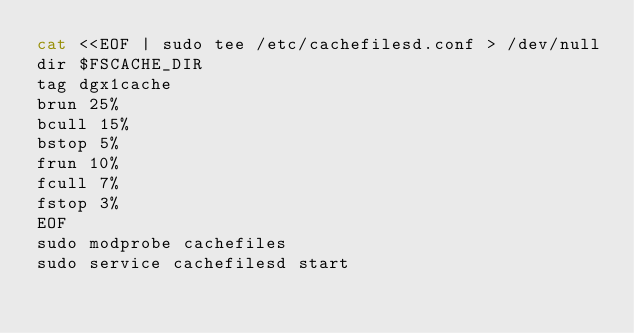<code> <loc_0><loc_0><loc_500><loc_500><_Bash_>cat <<EOF | sudo tee /etc/cachefilesd.conf > /dev/null
dir $FSCACHE_DIR
tag dgx1cache
brun 25%
bcull 15%
bstop 5%
frun 10%
fcull 7%
fstop 3%
EOF
sudo modprobe cachefiles
sudo service cachefilesd start

</code> 